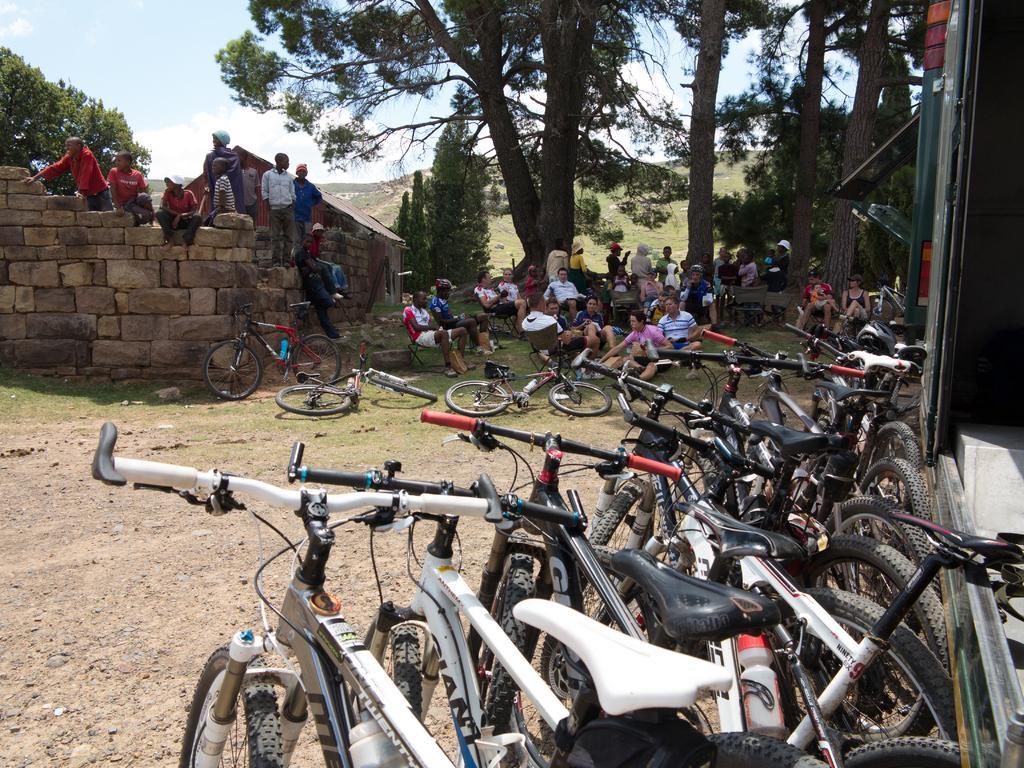Can you describe this image briefly? This image is taken outdoors. At the bottom of the image there is a ground with grass on it and many bicycles are parked on the ground. At the top of the image there is a sky with clouds. In the background there are a few trees and plants. A few people are sitting on the wall. Many people are sitting on the ground and there are a few bicycles on the ground. 